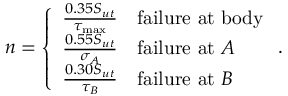Convert formula to latex. <formula><loc_0><loc_0><loc_500><loc_500>n = \left \{ \begin{array} { l l } { \frac { 0 . 3 5 S _ { u t } } { \tau _ { \max } } } & { f a i l u r e \ a t \ b o d y } \\ { \frac { 0 . 5 5 S _ { u t } } { \sigma _ { A } } } & { f a i l u r e \ a t \ A } \\ { \frac { 0 . 3 0 S _ { u t } } { \tau _ { B } } } & { f a i l u r e \ a t \ B } \end{array} .</formula> 